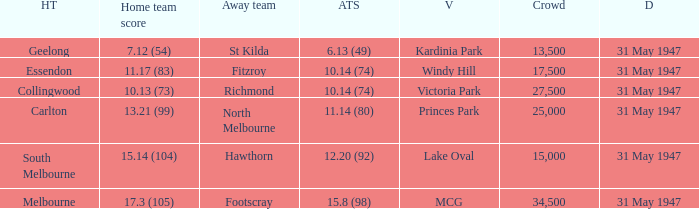What day is south melbourne at home? 31 May 1947. 